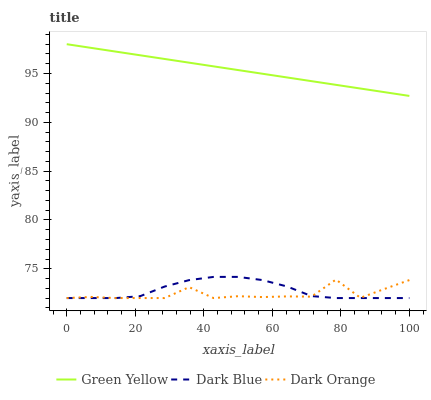Does Dark Orange have the minimum area under the curve?
Answer yes or no. Yes. Does Green Yellow have the maximum area under the curve?
Answer yes or no. Yes. Does Green Yellow have the minimum area under the curve?
Answer yes or no. No. Does Dark Orange have the maximum area under the curve?
Answer yes or no. No. Is Green Yellow the smoothest?
Answer yes or no. Yes. Is Dark Orange the roughest?
Answer yes or no. Yes. Is Dark Orange the smoothest?
Answer yes or no. No. Is Green Yellow the roughest?
Answer yes or no. No. Does Green Yellow have the lowest value?
Answer yes or no. No. Does Dark Orange have the highest value?
Answer yes or no. No. Is Dark Blue less than Green Yellow?
Answer yes or no. Yes. Is Green Yellow greater than Dark Blue?
Answer yes or no. Yes. Does Dark Blue intersect Green Yellow?
Answer yes or no. No. 